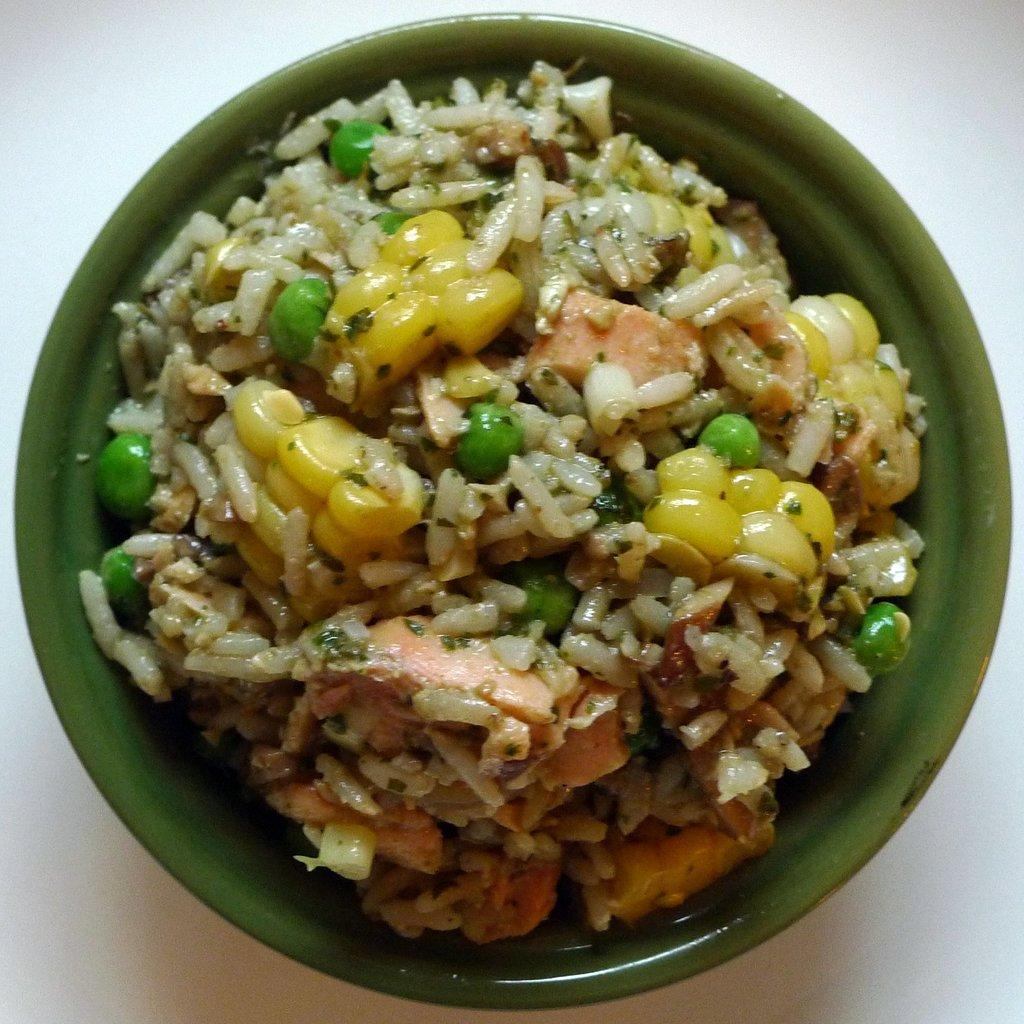What is in the bowl that is visible in the image? There is food in a bowl in the image. What is the color of the bowl? The bowl is green in color. What type of surface is the bowl resting on in the image? There appears to be a table at the bottom of the image. How many cars are parked on the sofa in the image? There are no cars or sofas present in the image. 